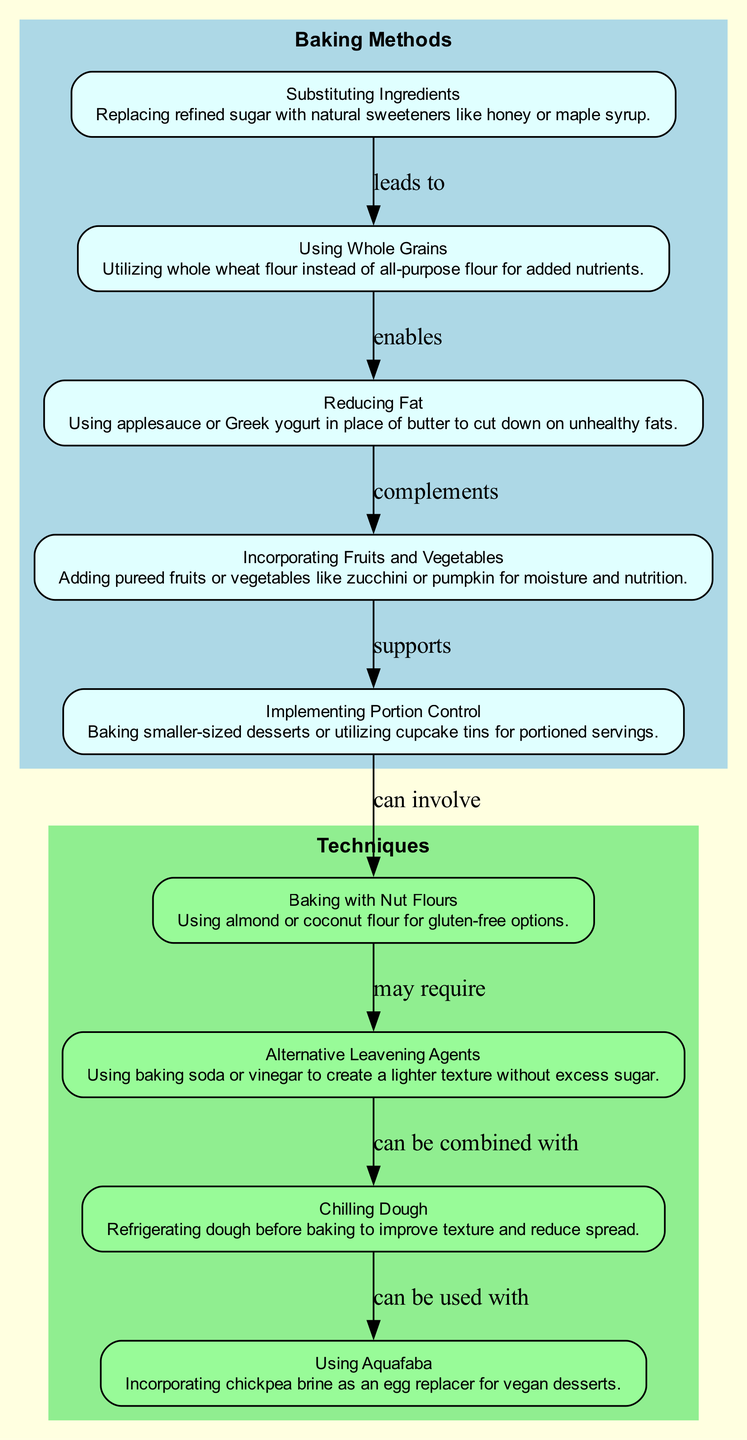What is the first baking method in the diagram? The first node in the directed graph under "Baking Methods" is "Substituting Ingredients." This is identified by its position at the top of the graph, which typically indicates the starting point in flow diagrams.
Answer: Substituting Ingredients How many baking methods are included in the diagram? There are five nodes listed under "Baking Methods" in the diagram. They are clearly separated, each representing a different method, so counting them gives us the total.
Answer: 5 What technique follows "Baking with Nut Flours" in the diagram? The edge leading from "Baking with Nut Flours" points to "Alternative Leavening Agents," indicating that this technique follows next in the flow of methods and techniques.
Answer: Alternative Leavening Agents Which baking method complements "Reducing Fat"? The directed edge shows that "Incorporating Fruits and Vegetables" is represented as complementing "Reducing Fat." The relationship demonstrates that incorporating these ingredients goes hand in hand with reducing fat in desserts.
Answer: Incorporating Fruits and Vegetables What is the direct connection between "Implementing Portion Control" and "Baking with Nut Flours"? The diagram shows an edge labeled "can involve," which indicates a direct relationship from "Implementing Portion Control" to "Baking with Nut Flours." This signifies that portion control can involve the use of nut flours in healthy desserts.
Answer: can involve Which technique can be used with "Chilling Dough"? The edge from "Chilling Dough" points to "Using Aquafaba," indicating that these two techniques are related, with "Using Aquafaba" being a suitable method to use alongside "Chilling Dough."
Answer: Using Aquafaba How many total edges are present in the diagram? By analyzing the connections (edges) between the nodes thoroughly, the diagram showcases eight edges that represent relationships between various methods and techniques.
Answer: 8 Which baking method enables "Reducing Fat"? The edge labeled "enables" leads from "Using Whole Grains," indicating that using whole grains enables the reduction of fat in dessert recipes. This explains how healthier ingredient choices can be interlinked.
Answer: Using Whole Grains 